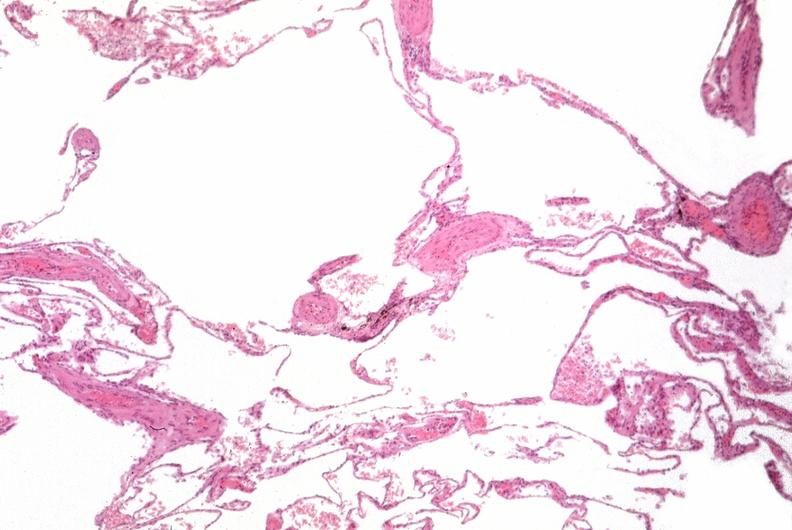what does this image show?
Answer the question using a single word or phrase. Lung 